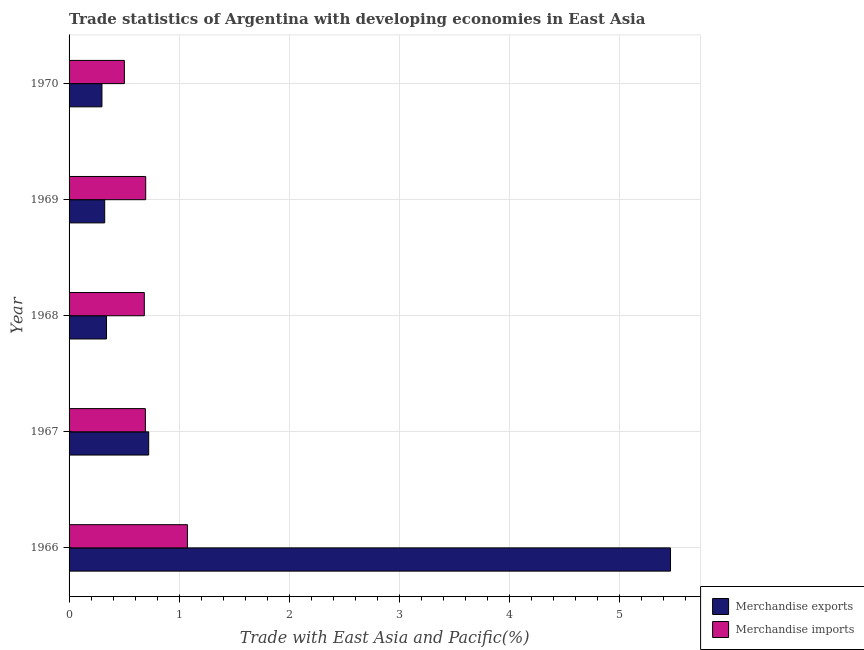How many groups of bars are there?
Give a very brief answer. 5. Are the number of bars on each tick of the Y-axis equal?
Your response must be concise. Yes. What is the label of the 2nd group of bars from the top?
Your answer should be very brief. 1969. In how many cases, is the number of bars for a given year not equal to the number of legend labels?
Give a very brief answer. 0. What is the merchandise imports in 1970?
Offer a very short reply. 0.5. Across all years, what is the maximum merchandise imports?
Offer a very short reply. 1.08. Across all years, what is the minimum merchandise exports?
Keep it short and to the point. 0.3. In which year was the merchandise exports maximum?
Your answer should be compact. 1966. What is the total merchandise imports in the graph?
Your answer should be compact. 3.65. What is the difference between the merchandise exports in 1969 and that in 1970?
Your answer should be compact. 0.03. What is the difference between the merchandise exports in 1967 and the merchandise imports in 1969?
Your response must be concise. 0.03. What is the average merchandise imports per year?
Your response must be concise. 0.73. In the year 1969, what is the difference between the merchandise imports and merchandise exports?
Your answer should be very brief. 0.37. In how many years, is the merchandise imports greater than 0.2 %?
Offer a very short reply. 5. What is the ratio of the merchandise exports in 1966 to that in 1970?
Give a very brief answer. 18.29. What is the difference between the highest and the second highest merchandise imports?
Give a very brief answer. 0.38. What is the difference between the highest and the lowest merchandise exports?
Give a very brief answer. 5.17. In how many years, is the merchandise imports greater than the average merchandise imports taken over all years?
Offer a very short reply. 1. Is the sum of the merchandise imports in 1968 and 1970 greater than the maximum merchandise exports across all years?
Make the answer very short. No. What does the 1st bar from the top in 1968 represents?
Provide a succinct answer. Merchandise imports. How many bars are there?
Your answer should be very brief. 10. How many years are there in the graph?
Your response must be concise. 5. What is the difference between two consecutive major ticks on the X-axis?
Ensure brevity in your answer.  1. Are the values on the major ticks of X-axis written in scientific E-notation?
Offer a very short reply. No. Does the graph contain any zero values?
Offer a terse response. No. Does the graph contain grids?
Provide a succinct answer. Yes. How many legend labels are there?
Provide a short and direct response. 2. What is the title of the graph?
Provide a short and direct response. Trade statistics of Argentina with developing economies in East Asia. Does "Exports of goods" appear as one of the legend labels in the graph?
Offer a terse response. No. What is the label or title of the X-axis?
Give a very brief answer. Trade with East Asia and Pacific(%). What is the label or title of the Y-axis?
Offer a terse response. Year. What is the Trade with East Asia and Pacific(%) in Merchandise exports in 1966?
Provide a succinct answer. 5.47. What is the Trade with East Asia and Pacific(%) of Merchandise imports in 1966?
Make the answer very short. 1.08. What is the Trade with East Asia and Pacific(%) of Merchandise exports in 1967?
Offer a terse response. 0.72. What is the Trade with East Asia and Pacific(%) in Merchandise imports in 1967?
Give a very brief answer. 0.69. What is the Trade with East Asia and Pacific(%) of Merchandise exports in 1968?
Make the answer very short. 0.34. What is the Trade with East Asia and Pacific(%) in Merchandise imports in 1968?
Give a very brief answer. 0.68. What is the Trade with East Asia and Pacific(%) of Merchandise exports in 1969?
Offer a very short reply. 0.32. What is the Trade with East Asia and Pacific(%) in Merchandise imports in 1969?
Offer a terse response. 0.7. What is the Trade with East Asia and Pacific(%) of Merchandise exports in 1970?
Your response must be concise. 0.3. What is the Trade with East Asia and Pacific(%) of Merchandise imports in 1970?
Give a very brief answer. 0.5. Across all years, what is the maximum Trade with East Asia and Pacific(%) in Merchandise exports?
Give a very brief answer. 5.47. Across all years, what is the maximum Trade with East Asia and Pacific(%) in Merchandise imports?
Provide a short and direct response. 1.08. Across all years, what is the minimum Trade with East Asia and Pacific(%) in Merchandise exports?
Your answer should be very brief. 0.3. Across all years, what is the minimum Trade with East Asia and Pacific(%) of Merchandise imports?
Offer a very short reply. 0.5. What is the total Trade with East Asia and Pacific(%) of Merchandise exports in the graph?
Provide a short and direct response. 7.15. What is the total Trade with East Asia and Pacific(%) of Merchandise imports in the graph?
Give a very brief answer. 3.65. What is the difference between the Trade with East Asia and Pacific(%) of Merchandise exports in 1966 and that in 1967?
Your answer should be compact. 4.74. What is the difference between the Trade with East Asia and Pacific(%) in Merchandise imports in 1966 and that in 1967?
Ensure brevity in your answer.  0.38. What is the difference between the Trade with East Asia and Pacific(%) of Merchandise exports in 1966 and that in 1968?
Ensure brevity in your answer.  5.13. What is the difference between the Trade with East Asia and Pacific(%) of Merchandise imports in 1966 and that in 1968?
Your response must be concise. 0.39. What is the difference between the Trade with East Asia and Pacific(%) in Merchandise exports in 1966 and that in 1969?
Provide a succinct answer. 5.14. What is the difference between the Trade with East Asia and Pacific(%) of Merchandise imports in 1966 and that in 1969?
Your answer should be compact. 0.38. What is the difference between the Trade with East Asia and Pacific(%) in Merchandise exports in 1966 and that in 1970?
Provide a succinct answer. 5.17. What is the difference between the Trade with East Asia and Pacific(%) of Merchandise imports in 1966 and that in 1970?
Keep it short and to the point. 0.57. What is the difference between the Trade with East Asia and Pacific(%) of Merchandise exports in 1967 and that in 1968?
Your response must be concise. 0.38. What is the difference between the Trade with East Asia and Pacific(%) of Merchandise imports in 1967 and that in 1968?
Keep it short and to the point. 0.01. What is the difference between the Trade with East Asia and Pacific(%) of Merchandise exports in 1967 and that in 1969?
Your answer should be very brief. 0.4. What is the difference between the Trade with East Asia and Pacific(%) of Merchandise imports in 1967 and that in 1969?
Ensure brevity in your answer.  -0. What is the difference between the Trade with East Asia and Pacific(%) of Merchandise exports in 1967 and that in 1970?
Make the answer very short. 0.42. What is the difference between the Trade with East Asia and Pacific(%) in Merchandise imports in 1967 and that in 1970?
Provide a succinct answer. 0.19. What is the difference between the Trade with East Asia and Pacific(%) in Merchandise exports in 1968 and that in 1969?
Your response must be concise. 0.02. What is the difference between the Trade with East Asia and Pacific(%) in Merchandise imports in 1968 and that in 1969?
Provide a succinct answer. -0.01. What is the difference between the Trade with East Asia and Pacific(%) of Merchandise exports in 1968 and that in 1970?
Keep it short and to the point. 0.04. What is the difference between the Trade with East Asia and Pacific(%) of Merchandise imports in 1968 and that in 1970?
Keep it short and to the point. 0.18. What is the difference between the Trade with East Asia and Pacific(%) of Merchandise exports in 1969 and that in 1970?
Your answer should be compact. 0.03. What is the difference between the Trade with East Asia and Pacific(%) in Merchandise imports in 1969 and that in 1970?
Make the answer very short. 0.19. What is the difference between the Trade with East Asia and Pacific(%) of Merchandise exports in 1966 and the Trade with East Asia and Pacific(%) of Merchandise imports in 1967?
Offer a very short reply. 4.77. What is the difference between the Trade with East Asia and Pacific(%) of Merchandise exports in 1966 and the Trade with East Asia and Pacific(%) of Merchandise imports in 1968?
Make the answer very short. 4.78. What is the difference between the Trade with East Asia and Pacific(%) in Merchandise exports in 1966 and the Trade with East Asia and Pacific(%) in Merchandise imports in 1969?
Offer a very short reply. 4.77. What is the difference between the Trade with East Asia and Pacific(%) in Merchandise exports in 1966 and the Trade with East Asia and Pacific(%) in Merchandise imports in 1970?
Offer a terse response. 4.96. What is the difference between the Trade with East Asia and Pacific(%) in Merchandise exports in 1967 and the Trade with East Asia and Pacific(%) in Merchandise imports in 1968?
Provide a succinct answer. 0.04. What is the difference between the Trade with East Asia and Pacific(%) in Merchandise exports in 1967 and the Trade with East Asia and Pacific(%) in Merchandise imports in 1969?
Offer a terse response. 0.03. What is the difference between the Trade with East Asia and Pacific(%) in Merchandise exports in 1967 and the Trade with East Asia and Pacific(%) in Merchandise imports in 1970?
Your response must be concise. 0.22. What is the difference between the Trade with East Asia and Pacific(%) of Merchandise exports in 1968 and the Trade with East Asia and Pacific(%) of Merchandise imports in 1969?
Provide a short and direct response. -0.36. What is the difference between the Trade with East Asia and Pacific(%) in Merchandise exports in 1968 and the Trade with East Asia and Pacific(%) in Merchandise imports in 1970?
Provide a succinct answer. -0.16. What is the difference between the Trade with East Asia and Pacific(%) in Merchandise exports in 1969 and the Trade with East Asia and Pacific(%) in Merchandise imports in 1970?
Your response must be concise. -0.18. What is the average Trade with East Asia and Pacific(%) in Merchandise exports per year?
Your answer should be very brief. 1.43. What is the average Trade with East Asia and Pacific(%) of Merchandise imports per year?
Your response must be concise. 0.73. In the year 1966, what is the difference between the Trade with East Asia and Pacific(%) of Merchandise exports and Trade with East Asia and Pacific(%) of Merchandise imports?
Make the answer very short. 4.39. In the year 1968, what is the difference between the Trade with East Asia and Pacific(%) in Merchandise exports and Trade with East Asia and Pacific(%) in Merchandise imports?
Provide a succinct answer. -0.34. In the year 1969, what is the difference between the Trade with East Asia and Pacific(%) of Merchandise exports and Trade with East Asia and Pacific(%) of Merchandise imports?
Keep it short and to the point. -0.37. In the year 1970, what is the difference between the Trade with East Asia and Pacific(%) in Merchandise exports and Trade with East Asia and Pacific(%) in Merchandise imports?
Your answer should be compact. -0.2. What is the ratio of the Trade with East Asia and Pacific(%) of Merchandise exports in 1966 to that in 1967?
Offer a terse response. 7.55. What is the ratio of the Trade with East Asia and Pacific(%) in Merchandise imports in 1966 to that in 1967?
Make the answer very short. 1.55. What is the ratio of the Trade with East Asia and Pacific(%) of Merchandise exports in 1966 to that in 1968?
Your answer should be compact. 16.06. What is the ratio of the Trade with East Asia and Pacific(%) in Merchandise imports in 1966 to that in 1968?
Make the answer very short. 1.57. What is the ratio of the Trade with East Asia and Pacific(%) in Merchandise exports in 1966 to that in 1969?
Offer a terse response. 16.88. What is the ratio of the Trade with East Asia and Pacific(%) in Merchandise imports in 1966 to that in 1969?
Give a very brief answer. 1.54. What is the ratio of the Trade with East Asia and Pacific(%) in Merchandise exports in 1966 to that in 1970?
Offer a terse response. 18.29. What is the ratio of the Trade with East Asia and Pacific(%) in Merchandise imports in 1966 to that in 1970?
Offer a very short reply. 2.14. What is the ratio of the Trade with East Asia and Pacific(%) in Merchandise exports in 1967 to that in 1968?
Provide a short and direct response. 2.13. What is the ratio of the Trade with East Asia and Pacific(%) of Merchandise imports in 1967 to that in 1968?
Give a very brief answer. 1.01. What is the ratio of the Trade with East Asia and Pacific(%) of Merchandise exports in 1967 to that in 1969?
Keep it short and to the point. 2.23. What is the ratio of the Trade with East Asia and Pacific(%) in Merchandise exports in 1967 to that in 1970?
Keep it short and to the point. 2.42. What is the ratio of the Trade with East Asia and Pacific(%) of Merchandise imports in 1967 to that in 1970?
Keep it short and to the point. 1.38. What is the ratio of the Trade with East Asia and Pacific(%) in Merchandise exports in 1968 to that in 1969?
Your response must be concise. 1.05. What is the ratio of the Trade with East Asia and Pacific(%) in Merchandise imports in 1968 to that in 1969?
Your response must be concise. 0.98. What is the ratio of the Trade with East Asia and Pacific(%) in Merchandise exports in 1968 to that in 1970?
Give a very brief answer. 1.14. What is the ratio of the Trade with East Asia and Pacific(%) in Merchandise imports in 1968 to that in 1970?
Keep it short and to the point. 1.36. What is the ratio of the Trade with East Asia and Pacific(%) in Merchandise exports in 1969 to that in 1970?
Keep it short and to the point. 1.08. What is the ratio of the Trade with East Asia and Pacific(%) in Merchandise imports in 1969 to that in 1970?
Make the answer very short. 1.39. What is the difference between the highest and the second highest Trade with East Asia and Pacific(%) of Merchandise exports?
Provide a short and direct response. 4.74. What is the difference between the highest and the second highest Trade with East Asia and Pacific(%) of Merchandise imports?
Ensure brevity in your answer.  0.38. What is the difference between the highest and the lowest Trade with East Asia and Pacific(%) of Merchandise exports?
Your answer should be very brief. 5.17. What is the difference between the highest and the lowest Trade with East Asia and Pacific(%) in Merchandise imports?
Ensure brevity in your answer.  0.57. 